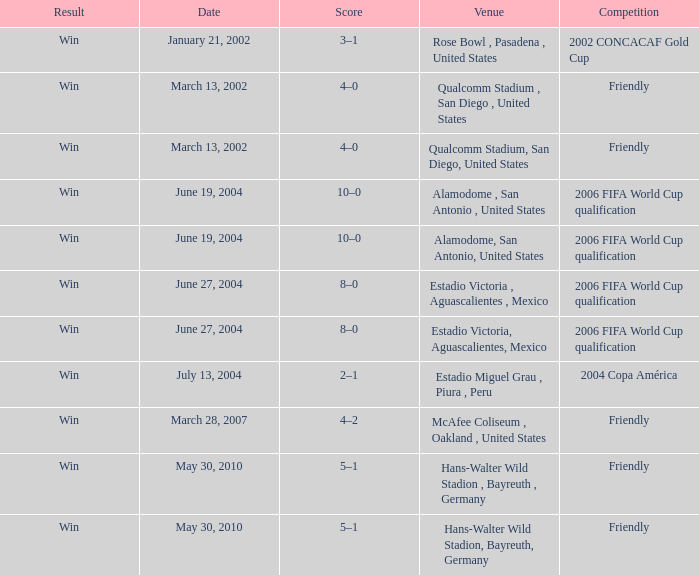What date has 2006 fifa world cup qualification as the competition, and alamodome, san antonio, united States as the venue? June 19, 2004, June 19, 2004. 